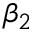<formula> <loc_0><loc_0><loc_500><loc_500>\beta _ { 2 }</formula> 